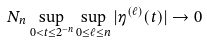Convert formula to latex. <formula><loc_0><loc_0><loc_500><loc_500>N _ { n } \sup _ { 0 < t \leq 2 ^ { - n } } \sup _ { 0 \leq \ell \leq n } | \eta ^ { ( \ell ) } ( t ) | \to 0</formula> 